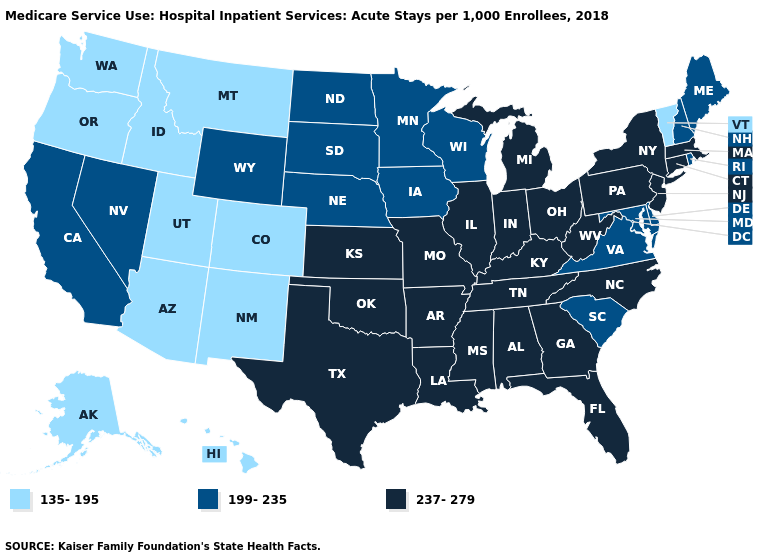Among the states that border Utah , does Nevada have the highest value?
Concise answer only. Yes. What is the value of Washington?
Short answer required. 135-195. Name the states that have a value in the range 135-195?
Quick response, please. Alaska, Arizona, Colorado, Hawaii, Idaho, Montana, New Mexico, Oregon, Utah, Vermont, Washington. What is the value of Arkansas?
Concise answer only. 237-279. Which states have the highest value in the USA?
Write a very short answer. Alabama, Arkansas, Connecticut, Florida, Georgia, Illinois, Indiana, Kansas, Kentucky, Louisiana, Massachusetts, Michigan, Mississippi, Missouri, New Jersey, New York, North Carolina, Ohio, Oklahoma, Pennsylvania, Tennessee, Texas, West Virginia. What is the lowest value in the MidWest?
Answer briefly. 199-235. Name the states that have a value in the range 135-195?
Short answer required. Alaska, Arizona, Colorado, Hawaii, Idaho, Montana, New Mexico, Oregon, Utah, Vermont, Washington. Name the states that have a value in the range 199-235?
Short answer required. California, Delaware, Iowa, Maine, Maryland, Minnesota, Nebraska, Nevada, New Hampshire, North Dakota, Rhode Island, South Carolina, South Dakota, Virginia, Wisconsin, Wyoming. Name the states that have a value in the range 199-235?
Answer briefly. California, Delaware, Iowa, Maine, Maryland, Minnesota, Nebraska, Nevada, New Hampshire, North Dakota, Rhode Island, South Carolina, South Dakota, Virginia, Wisconsin, Wyoming. What is the value of Colorado?
Quick response, please. 135-195. What is the value of Oregon?
Short answer required. 135-195. Which states have the lowest value in the South?
Quick response, please. Delaware, Maryland, South Carolina, Virginia. What is the highest value in the West ?
Answer briefly. 199-235. What is the value of Illinois?
Write a very short answer. 237-279. What is the value of Maryland?
Keep it brief. 199-235. 